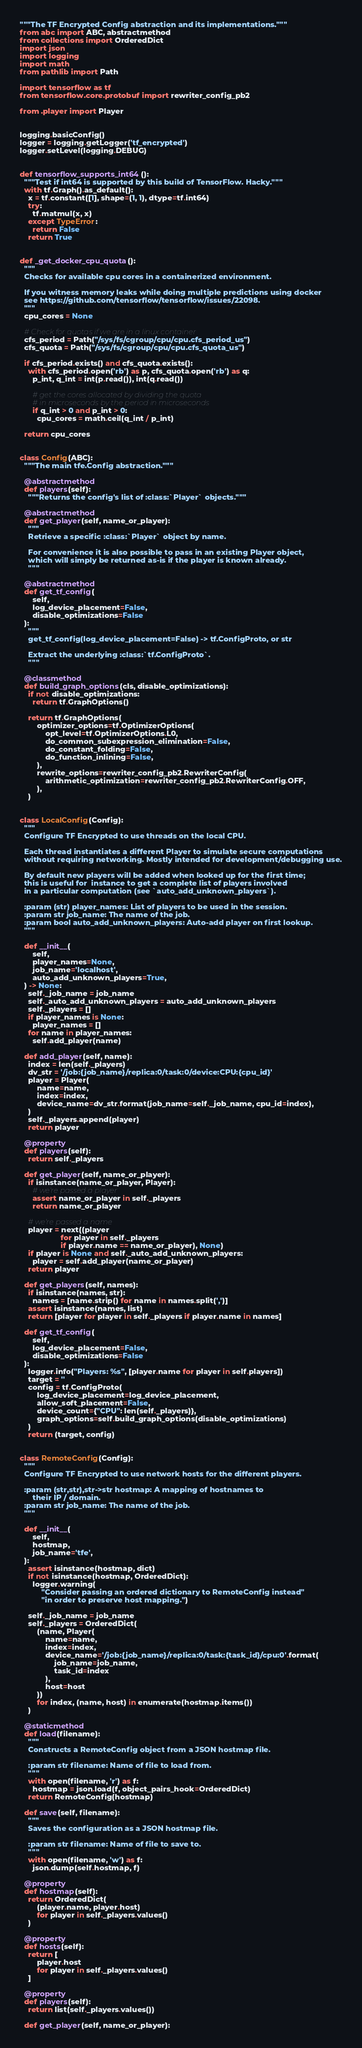Convert code to text. <code><loc_0><loc_0><loc_500><loc_500><_Python_>"""The TF Encrypted Config abstraction and its implementations."""
from abc import ABC, abstractmethod
from collections import OrderedDict
import json
import logging
import math
from pathlib import Path

import tensorflow as tf
from tensorflow.core.protobuf import rewriter_config_pb2

from .player import Player


logging.basicConfig()
logger = logging.getLogger('tf_encrypted')
logger.setLevel(logging.DEBUG)


def tensorflow_supports_int64():
  """Test if int64 is supported by this build of TensorFlow. Hacky."""
  with tf.Graph().as_default():
    x = tf.constant([1], shape=(1, 1), dtype=tf.int64)
    try:
      tf.matmul(x, x)
    except TypeError:
      return False
    return True


def _get_docker_cpu_quota():
  """
  Checks for available cpu cores in a containerized environment.

  If you witness memory leaks while doing multiple predictions using docker
  see https://github.com/tensorflow/tensorflow/issues/22098.
  """
  cpu_cores = None

  # Check for quotas if we are in a linux container
  cfs_period = Path("/sys/fs/cgroup/cpu/cpu.cfs_period_us")
  cfs_quota = Path("/sys/fs/cgroup/cpu/cpu.cfs_quota_us")

  if cfs_period.exists() and cfs_quota.exists():
    with cfs_period.open('rb') as p, cfs_quota.open('rb') as q:
      p_int, q_int = int(p.read()), int(q.read())

      # get the cores allocated by dividing the quota
      # in microseconds by the period in microseconds
      if q_int > 0 and p_int > 0:
        cpu_cores = math.ceil(q_int / p_int)

  return cpu_cores


class Config(ABC):
  """The main tfe.Config abstraction."""

  @abstractmethod
  def players(self):
    """Returns the config's list of :class:`Player` objects."""

  @abstractmethod
  def get_player(self, name_or_player):
    """
    Retrieve a specific :class:`Player` object by name.

    For convenience it is also possible to pass in an existing Player object,
    which will simply be returned as-is if the player is known already.
    """

  @abstractmethod
  def get_tf_config(
      self,
      log_device_placement=False,
      disable_optimizations=False
  ):
    """
    get_tf_config(log_device_placement=False) -> tf.ConfigProto, or str

    Extract the underlying :class:`tf.ConfigProto`.
    """

  @classmethod
  def build_graph_options(cls, disable_optimizations):
    if not disable_optimizations:
      return tf.GraphOptions()

    return tf.GraphOptions(
        optimizer_options=tf.OptimizerOptions(
            opt_level=tf.OptimizerOptions.L0,
            do_common_subexpression_elimination=False,
            do_constant_folding=False,
            do_function_inlining=False,
        ),
        rewrite_options=rewriter_config_pb2.RewriterConfig(
            arithmetic_optimization=rewriter_config_pb2.RewriterConfig.OFF,
        ),
    )


class LocalConfig(Config):
  """
  Configure TF Encrypted to use threads on the local CPU.

  Each thread instantiates a different Player to simulate secure computations
  without requiring networking. Mostly intended for development/debugging use.

  By default new players will be added when looked up for the first time;
  this is useful for  instance to get a complete list of players involved
  in a particular computation (see `auto_add_unknown_players`).

  :param (str) player_names: List of players to be used in the session.
  :param str job_name: The name of the job.
  :param bool auto_add_unknown_players: Auto-add player on first lookup.
  """

  def __init__(
      self,
      player_names=None,
      job_name='localhost',
      auto_add_unknown_players=True,
  ) -> None:
    self._job_name = job_name
    self._auto_add_unknown_players = auto_add_unknown_players
    self._players = []
    if player_names is None:
      player_names = []
    for name in player_names:
      self.add_player(name)

  def add_player(self, name):
    index = len(self._players)
    dv_str = '/job:{job_name}/replica:0/task:0/device:CPU:{cpu_id}'
    player = Player(
        name=name,
        index=index,
        device_name=dv_str.format(job_name=self._job_name, cpu_id=index),
    )
    self._players.append(player)
    return player

  @property
  def players(self):
    return self._players

  def get_player(self, name_or_player):
    if isinstance(name_or_player, Player):
      # we're passed a player
      assert name_or_player in self._players
      return name_or_player

    # we're passed a name
    player = next((player
                   for player in self._players
                   if player.name == name_or_player), None)
    if player is None and self._auto_add_unknown_players:
      player = self.add_player(name_or_player)
    return player

  def get_players(self, names):
    if isinstance(names, str):
      names = [name.strip() for name in names.split(',')]
    assert isinstance(names, list)
    return [player for player in self._players if player.name in names]

  def get_tf_config(
      self,
      log_device_placement=False,
      disable_optimizations=False
  ):
    logger.info("Players: %s", [player.name for player in self.players])
    target = ''
    config = tf.ConfigProto(
        log_device_placement=log_device_placement,
        allow_soft_placement=False,
        device_count={"CPU": len(self._players)},
        graph_options=self.build_graph_options(disable_optimizations)
    )
    return (target, config)


class RemoteConfig(Config):
  """
  Configure TF Encrypted to use network hosts for the different players.

  :param (str,str),str->str hostmap: A mapping of hostnames to
      their IP / domain.
  :param str job_name: The name of the job.
  """

  def __init__(
      self,
      hostmap,
      job_name='tfe',
  ):
    assert isinstance(hostmap, dict)
    if not isinstance(hostmap, OrderedDict):
      logger.warning(
          "Consider passing an ordered dictionary to RemoteConfig instead"
          "in order to preserve host mapping.")

    self._job_name = job_name
    self._players = OrderedDict(
        (name, Player(
            name=name,
            index=index,
            device_name='/job:{job_name}/replica:0/task:{task_id}/cpu:0'.format(
                job_name=job_name,
                task_id=index
            ),
            host=host
        ))
        for index, (name, host) in enumerate(hostmap.items())
    )

  @staticmethod
  def load(filename):
    """
    Constructs a RemoteConfig object from a JSON hostmap file.

    :param str filename: Name of file to load from.
    """
    with open(filename, 'r') as f:
      hostmap = json.load(f, object_pairs_hook=OrderedDict)
    return RemoteConfig(hostmap)

  def save(self, filename):
    """
    Saves the configuration as a JSON hostmap file.

    :param str filename: Name of file to save to.
    """
    with open(filename, 'w') as f:
      json.dump(self.hostmap, f)

  @property
  def hostmap(self):
    return OrderedDict(
        (player.name, player.host)
        for player in self._players.values()
    )

  @property
  def hosts(self):
    return [
        player.host
        for player in self._players.values()
    ]

  @property
  def players(self):
    return list(self._players.values())

  def get_player(self, name_or_player):</code> 